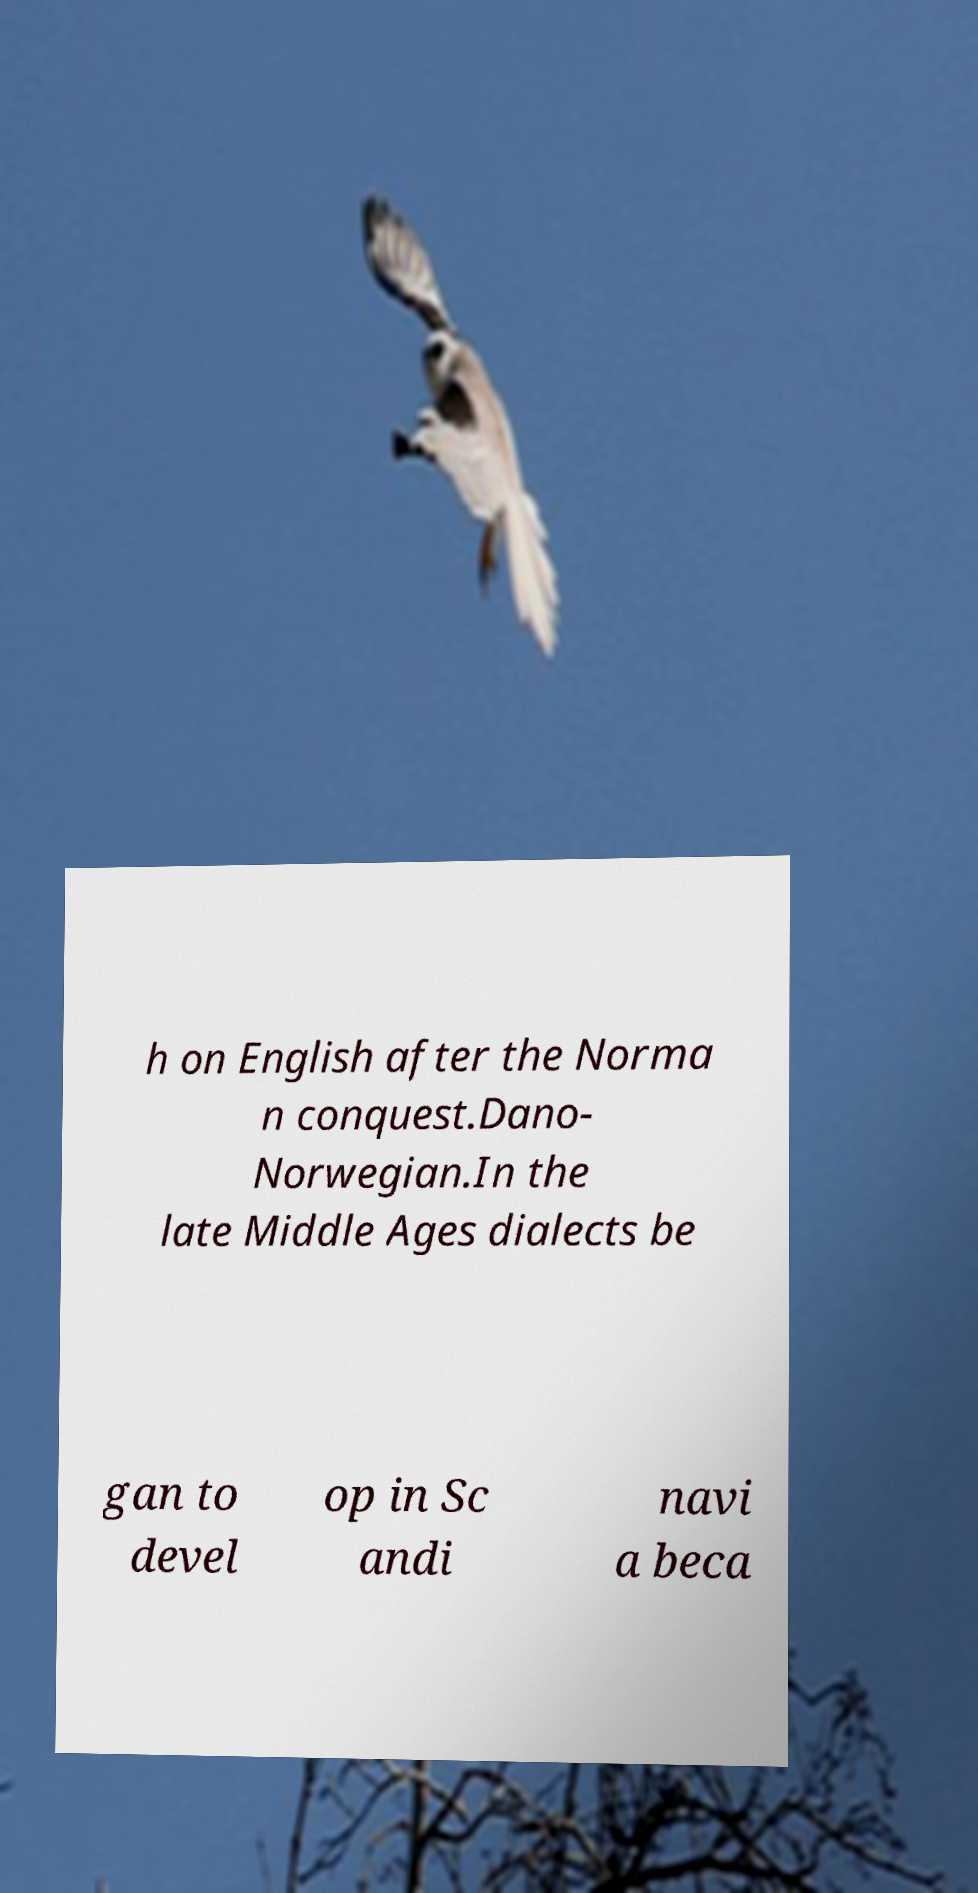Could you extract and type out the text from this image? h on English after the Norma n conquest.Dano- Norwegian.In the late Middle Ages dialects be gan to devel op in Sc andi navi a beca 